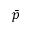Convert formula to latex. <formula><loc_0><loc_0><loc_500><loc_500>\bar { p }</formula> 